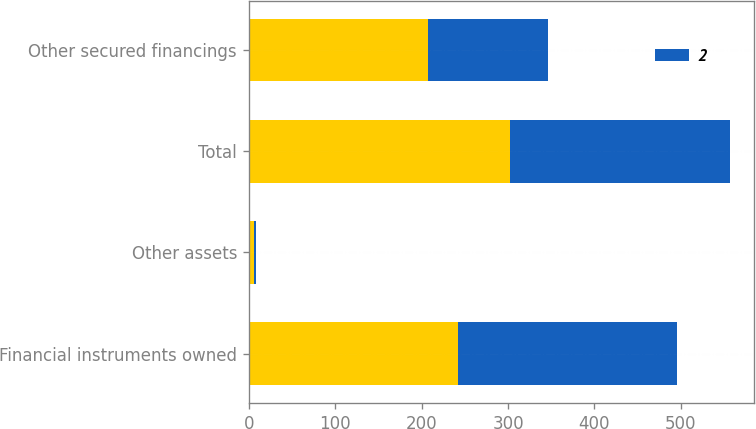<chart> <loc_0><loc_0><loc_500><loc_500><stacked_bar_chart><ecel><fcel>Financial instruments owned<fcel>Other assets<fcel>Total<fcel>Other secured financings<nl><fcel>nan<fcel>242<fcel>6<fcel>302<fcel>207<nl><fcel>2<fcel>253<fcel>2<fcel>255<fcel>139<nl></chart> 